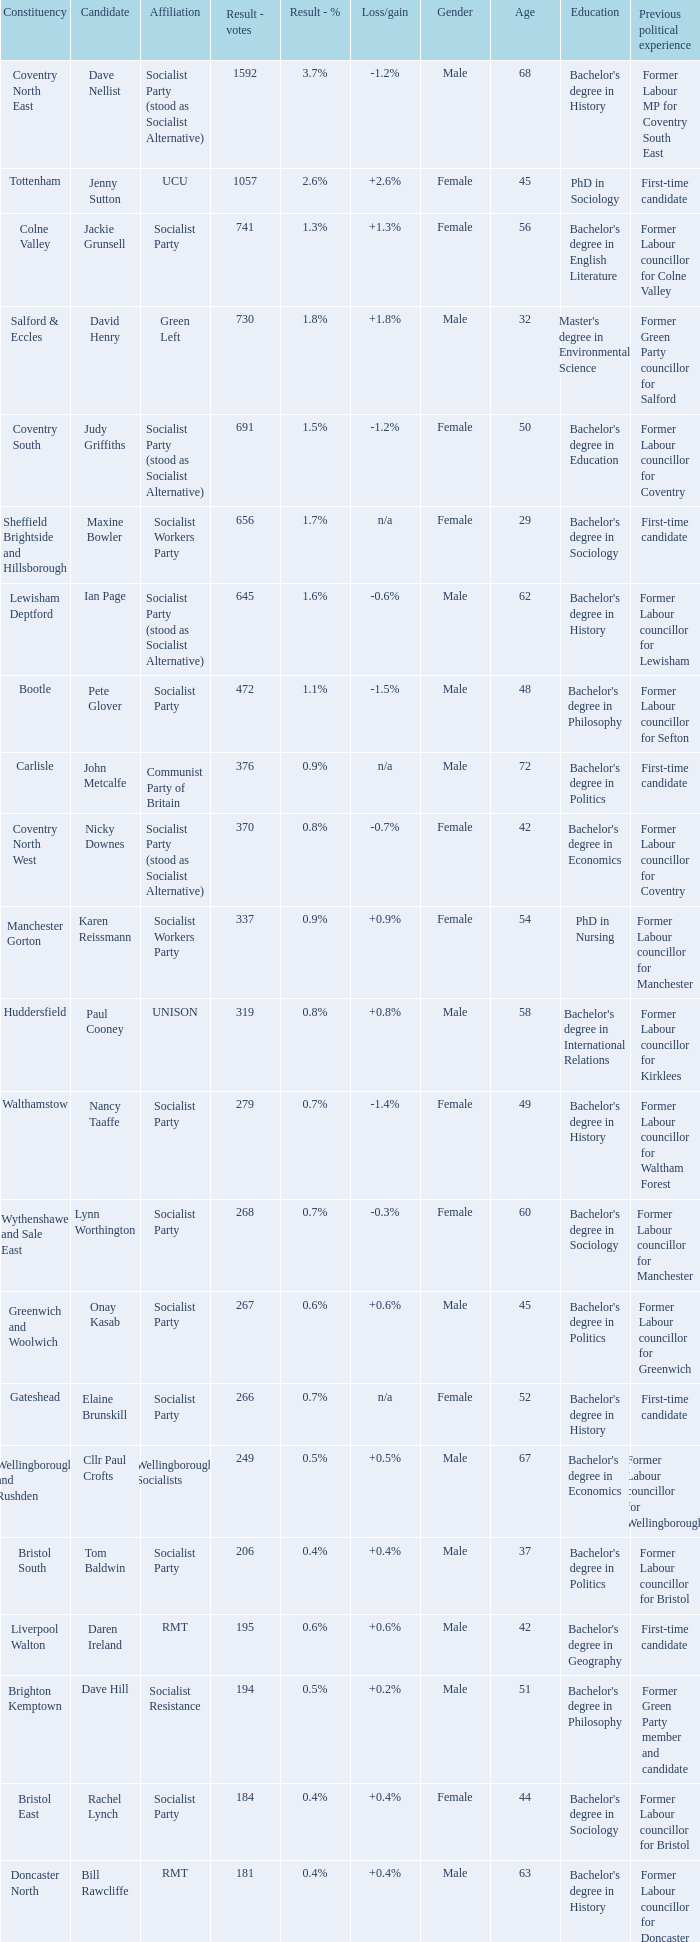How many values for constituency for the vote result of 162? 1.0. 